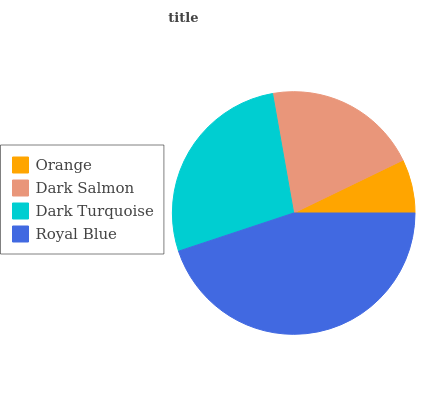Is Orange the minimum?
Answer yes or no. Yes. Is Royal Blue the maximum?
Answer yes or no. Yes. Is Dark Salmon the minimum?
Answer yes or no. No. Is Dark Salmon the maximum?
Answer yes or no. No. Is Dark Salmon greater than Orange?
Answer yes or no. Yes. Is Orange less than Dark Salmon?
Answer yes or no. Yes. Is Orange greater than Dark Salmon?
Answer yes or no. No. Is Dark Salmon less than Orange?
Answer yes or no. No. Is Dark Turquoise the high median?
Answer yes or no. Yes. Is Dark Salmon the low median?
Answer yes or no. Yes. Is Orange the high median?
Answer yes or no. No. Is Orange the low median?
Answer yes or no. No. 